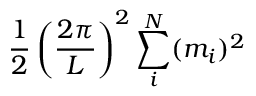<formula> <loc_0><loc_0><loc_500><loc_500>{ \frac { 1 } { 2 } } \left ( { \frac { 2 \pi } { L } } \right ) ^ { 2 } \sum _ { i } ^ { N } ( m _ { i } ) ^ { 2 }</formula> 